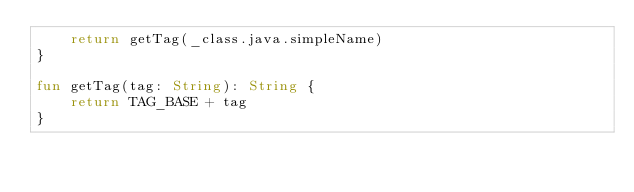Convert code to text. <code><loc_0><loc_0><loc_500><loc_500><_Kotlin_>    return getTag(_class.java.simpleName)
}

fun getTag(tag: String): String {
    return TAG_BASE + tag
}
</code> 